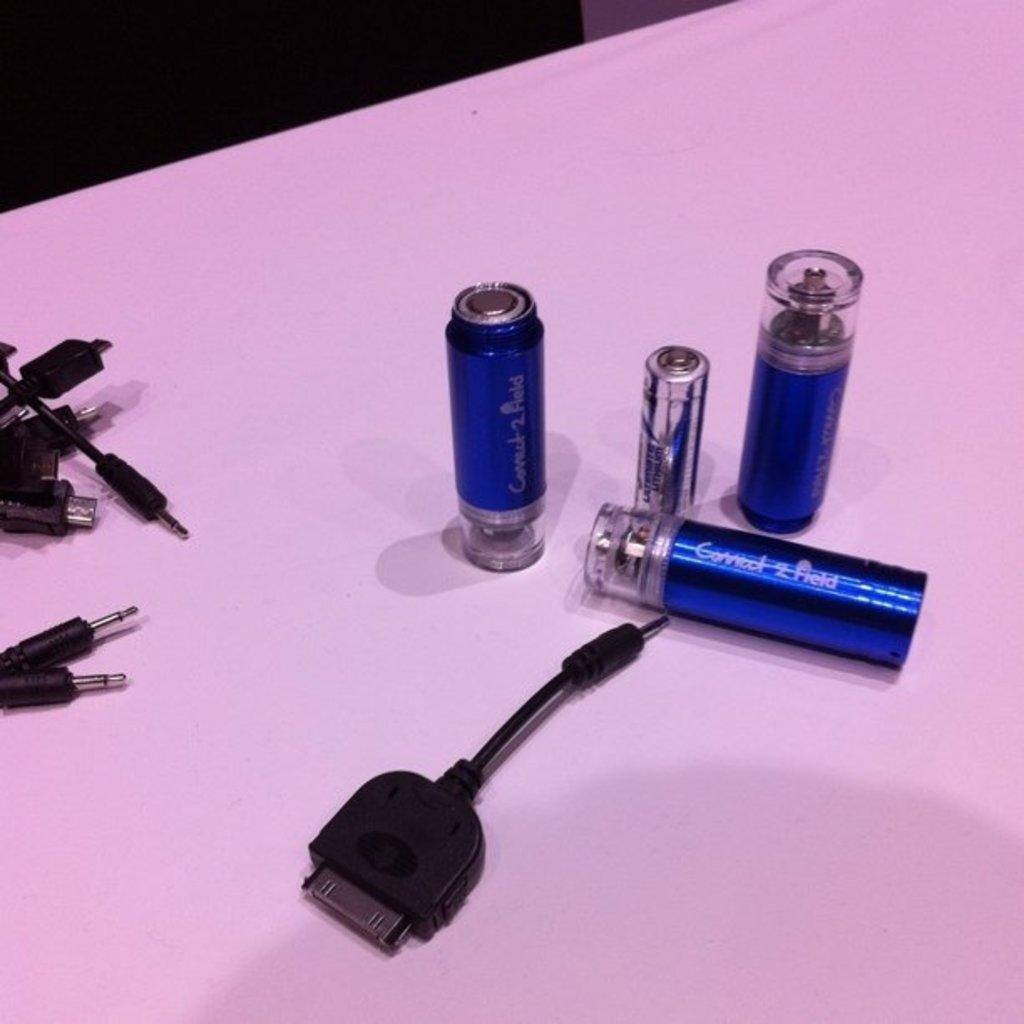<image>
Give a short and clear explanation of the subsequent image. Three Connect 2 Field canisters sit on a table. 